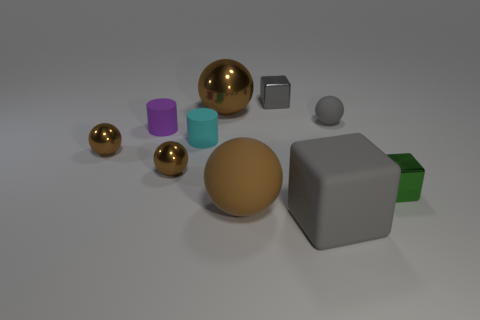There is a big object that is the same color as the big shiny sphere; what material is it?
Provide a short and direct response. Rubber. The big gray matte object is what shape?
Make the answer very short. Cube. Are there more purple rubber things right of the gray matte cube than tiny gray objects?
Provide a short and direct response. No. What is the shape of the tiny purple matte object that is behind the green shiny thing?
Keep it short and to the point. Cylinder. How many other objects are the same shape as the brown matte thing?
Offer a very short reply. 4. Are the big object on the right side of the brown matte thing and the tiny cyan object made of the same material?
Provide a succinct answer. Yes. Are there an equal number of cyan matte cylinders that are right of the tiny cyan matte cylinder and cyan objects on the left side of the tiny green shiny object?
Make the answer very short. No. There is a rubber ball on the right side of the big gray thing; how big is it?
Provide a short and direct response. Small. Is there a red cylinder that has the same material as the small gray cube?
Provide a succinct answer. No. Does the small metallic object right of the gray metal thing have the same color as the large block?
Keep it short and to the point. No. 